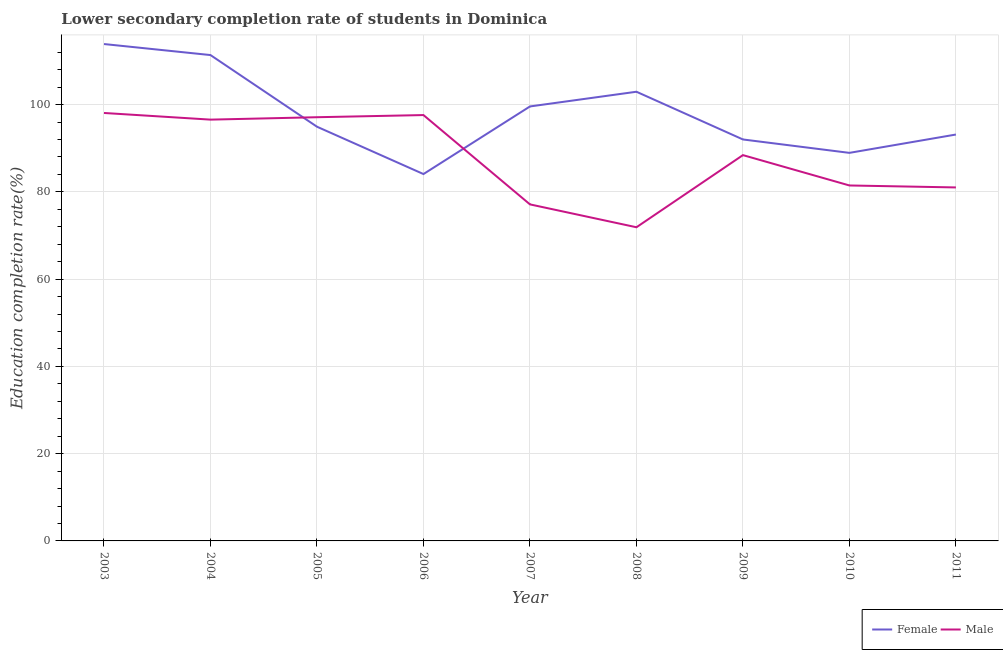Does the line corresponding to education completion rate of female students intersect with the line corresponding to education completion rate of male students?
Your answer should be very brief. Yes. What is the education completion rate of male students in 2005?
Your answer should be compact. 97.11. Across all years, what is the maximum education completion rate of male students?
Offer a terse response. 98.08. Across all years, what is the minimum education completion rate of male students?
Your answer should be compact. 71.89. In which year was the education completion rate of female students minimum?
Your answer should be very brief. 2006. What is the total education completion rate of female students in the graph?
Your response must be concise. 880.86. What is the difference between the education completion rate of male students in 2008 and that in 2011?
Provide a succinct answer. -9.13. What is the difference between the education completion rate of female students in 2005 and the education completion rate of male students in 2007?
Make the answer very short. 17.8. What is the average education completion rate of male students per year?
Provide a succinct answer. 87.7. In the year 2008, what is the difference between the education completion rate of female students and education completion rate of male students?
Make the answer very short. 31.06. In how many years, is the education completion rate of female students greater than 96 %?
Provide a succinct answer. 4. What is the ratio of the education completion rate of female students in 2007 to that in 2009?
Your answer should be very brief. 1.08. What is the difference between the highest and the second highest education completion rate of female students?
Your answer should be very brief. 2.53. What is the difference between the highest and the lowest education completion rate of female students?
Provide a short and direct response. 29.8. In how many years, is the education completion rate of female students greater than the average education completion rate of female students taken over all years?
Your answer should be compact. 4. Is the sum of the education completion rate of male students in 2006 and 2010 greater than the maximum education completion rate of female students across all years?
Provide a short and direct response. Yes. Is the education completion rate of female students strictly greater than the education completion rate of male students over the years?
Your answer should be compact. No. How many years are there in the graph?
Your answer should be very brief. 9. What is the difference between two consecutive major ticks on the Y-axis?
Your answer should be very brief. 20. Does the graph contain any zero values?
Your answer should be compact. No. How many legend labels are there?
Ensure brevity in your answer.  2. What is the title of the graph?
Your answer should be very brief. Lower secondary completion rate of students in Dominica. What is the label or title of the Y-axis?
Give a very brief answer. Education completion rate(%). What is the Education completion rate(%) of Female in 2003?
Offer a terse response. 113.88. What is the Education completion rate(%) in Male in 2003?
Ensure brevity in your answer.  98.08. What is the Education completion rate(%) of Female in 2004?
Your answer should be compact. 111.35. What is the Education completion rate(%) of Male in 2004?
Provide a short and direct response. 96.56. What is the Education completion rate(%) of Female in 2005?
Offer a very short reply. 94.93. What is the Education completion rate(%) of Male in 2005?
Keep it short and to the point. 97.11. What is the Education completion rate(%) in Female in 2006?
Your answer should be compact. 84.08. What is the Education completion rate(%) in Male in 2006?
Make the answer very short. 97.6. What is the Education completion rate(%) in Female in 2007?
Provide a succinct answer. 99.58. What is the Education completion rate(%) of Male in 2007?
Offer a very short reply. 77.13. What is the Education completion rate(%) in Female in 2008?
Offer a very short reply. 102.95. What is the Education completion rate(%) of Male in 2008?
Your response must be concise. 71.89. What is the Education completion rate(%) in Female in 2009?
Offer a very short reply. 92.01. What is the Education completion rate(%) in Male in 2009?
Ensure brevity in your answer.  88.42. What is the Education completion rate(%) in Female in 2010?
Offer a very short reply. 88.94. What is the Education completion rate(%) of Male in 2010?
Your response must be concise. 81.47. What is the Education completion rate(%) of Female in 2011?
Provide a short and direct response. 93.14. What is the Education completion rate(%) in Male in 2011?
Your response must be concise. 81.01. Across all years, what is the maximum Education completion rate(%) in Female?
Make the answer very short. 113.88. Across all years, what is the maximum Education completion rate(%) of Male?
Ensure brevity in your answer.  98.08. Across all years, what is the minimum Education completion rate(%) in Female?
Ensure brevity in your answer.  84.08. Across all years, what is the minimum Education completion rate(%) in Male?
Provide a succinct answer. 71.89. What is the total Education completion rate(%) in Female in the graph?
Your answer should be very brief. 880.86. What is the total Education completion rate(%) in Male in the graph?
Your response must be concise. 789.27. What is the difference between the Education completion rate(%) in Female in 2003 and that in 2004?
Keep it short and to the point. 2.53. What is the difference between the Education completion rate(%) in Male in 2003 and that in 2004?
Give a very brief answer. 1.53. What is the difference between the Education completion rate(%) in Female in 2003 and that in 2005?
Your answer should be compact. 18.95. What is the difference between the Education completion rate(%) in Male in 2003 and that in 2005?
Provide a succinct answer. 0.98. What is the difference between the Education completion rate(%) of Female in 2003 and that in 2006?
Provide a short and direct response. 29.8. What is the difference between the Education completion rate(%) in Male in 2003 and that in 2006?
Your response must be concise. 0.48. What is the difference between the Education completion rate(%) in Female in 2003 and that in 2007?
Ensure brevity in your answer.  14.3. What is the difference between the Education completion rate(%) of Male in 2003 and that in 2007?
Offer a terse response. 20.95. What is the difference between the Education completion rate(%) of Female in 2003 and that in 2008?
Offer a terse response. 10.93. What is the difference between the Education completion rate(%) of Male in 2003 and that in 2008?
Offer a terse response. 26.2. What is the difference between the Education completion rate(%) of Female in 2003 and that in 2009?
Ensure brevity in your answer.  21.87. What is the difference between the Education completion rate(%) of Male in 2003 and that in 2009?
Your answer should be compact. 9.66. What is the difference between the Education completion rate(%) of Female in 2003 and that in 2010?
Your answer should be very brief. 24.94. What is the difference between the Education completion rate(%) of Male in 2003 and that in 2010?
Your answer should be compact. 16.62. What is the difference between the Education completion rate(%) of Female in 2003 and that in 2011?
Make the answer very short. 20.74. What is the difference between the Education completion rate(%) in Male in 2003 and that in 2011?
Provide a succinct answer. 17.07. What is the difference between the Education completion rate(%) in Female in 2004 and that in 2005?
Offer a very short reply. 16.42. What is the difference between the Education completion rate(%) in Male in 2004 and that in 2005?
Your answer should be compact. -0.55. What is the difference between the Education completion rate(%) in Female in 2004 and that in 2006?
Your response must be concise. 27.27. What is the difference between the Education completion rate(%) of Male in 2004 and that in 2006?
Your answer should be compact. -1.05. What is the difference between the Education completion rate(%) in Female in 2004 and that in 2007?
Provide a succinct answer. 11.78. What is the difference between the Education completion rate(%) in Male in 2004 and that in 2007?
Your response must be concise. 19.42. What is the difference between the Education completion rate(%) in Female in 2004 and that in 2008?
Your answer should be very brief. 8.41. What is the difference between the Education completion rate(%) in Male in 2004 and that in 2008?
Your answer should be compact. 24.67. What is the difference between the Education completion rate(%) of Female in 2004 and that in 2009?
Your answer should be very brief. 19.34. What is the difference between the Education completion rate(%) of Male in 2004 and that in 2009?
Ensure brevity in your answer.  8.14. What is the difference between the Education completion rate(%) in Female in 2004 and that in 2010?
Provide a succinct answer. 22.41. What is the difference between the Education completion rate(%) in Male in 2004 and that in 2010?
Offer a very short reply. 15.09. What is the difference between the Education completion rate(%) in Female in 2004 and that in 2011?
Your answer should be very brief. 18.21. What is the difference between the Education completion rate(%) of Male in 2004 and that in 2011?
Ensure brevity in your answer.  15.54. What is the difference between the Education completion rate(%) in Female in 2005 and that in 2006?
Ensure brevity in your answer.  10.85. What is the difference between the Education completion rate(%) in Male in 2005 and that in 2006?
Provide a short and direct response. -0.5. What is the difference between the Education completion rate(%) in Female in 2005 and that in 2007?
Your answer should be very brief. -4.64. What is the difference between the Education completion rate(%) in Male in 2005 and that in 2007?
Your answer should be very brief. 19.98. What is the difference between the Education completion rate(%) of Female in 2005 and that in 2008?
Offer a terse response. -8.01. What is the difference between the Education completion rate(%) in Male in 2005 and that in 2008?
Your answer should be very brief. 25.22. What is the difference between the Education completion rate(%) of Female in 2005 and that in 2009?
Your answer should be very brief. 2.92. What is the difference between the Education completion rate(%) of Male in 2005 and that in 2009?
Your response must be concise. 8.69. What is the difference between the Education completion rate(%) of Female in 2005 and that in 2010?
Make the answer very short. 5.99. What is the difference between the Education completion rate(%) in Male in 2005 and that in 2010?
Offer a terse response. 15.64. What is the difference between the Education completion rate(%) of Female in 2005 and that in 2011?
Provide a short and direct response. 1.79. What is the difference between the Education completion rate(%) of Male in 2005 and that in 2011?
Ensure brevity in your answer.  16.09. What is the difference between the Education completion rate(%) in Female in 2006 and that in 2007?
Offer a terse response. -15.5. What is the difference between the Education completion rate(%) of Male in 2006 and that in 2007?
Your response must be concise. 20.47. What is the difference between the Education completion rate(%) in Female in 2006 and that in 2008?
Offer a terse response. -18.86. What is the difference between the Education completion rate(%) in Male in 2006 and that in 2008?
Provide a short and direct response. 25.72. What is the difference between the Education completion rate(%) in Female in 2006 and that in 2009?
Ensure brevity in your answer.  -7.93. What is the difference between the Education completion rate(%) in Male in 2006 and that in 2009?
Make the answer very short. 9.18. What is the difference between the Education completion rate(%) of Female in 2006 and that in 2010?
Provide a succinct answer. -4.86. What is the difference between the Education completion rate(%) in Male in 2006 and that in 2010?
Your response must be concise. 16.14. What is the difference between the Education completion rate(%) of Female in 2006 and that in 2011?
Ensure brevity in your answer.  -9.06. What is the difference between the Education completion rate(%) of Male in 2006 and that in 2011?
Give a very brief answer. 16.59. What is the difference between the Education completion rate(%) in Female in 2007 and that in 2008?
Provide a succinct answer. -3.37. What is the difference between the Education completion rate(%) in Male in 2007 and that in 2008?
Provide a succinct answer. 5.24. What is the difference between the Education completion rate(%) in Female in 2007 and that in 2009?
Give a very brief answer. 7.56. What is the difference between the Education completion rate(%) of Male in 2007 and that in 2009?
Provide a short and direct response. -11.29. What is the difference between the Education completion rate(%) of Female in 2007 and that in 2010?
Your answer should be compact. 10.64. What is the difference between the Education completion rate(%) in Male in 2007 and that in 2010?
Keep it short and to the point. -4.33. What is the difference between the Education completion rate(%) of Female in 2007 and that in 2011?
Provide a short and direct response. 6.44. What is the difference between the Education completion rate(%) of Male in 2007 and that in 2011?
Offer a terse response. -3.88. What is the difference between the Education completion rate(%) in Female in 2008 and that in 2009?
Keep it short and to the point. 10.93. What is the difference between the Education completion rate(%) in Male in 2008 and that in 2009?
Give a very brief answer. -16.53. What is the difference between the Education completion rate(%) of Female in 2008 and that in 2010?
Offer a very short reply. 14.01. What is the difference between the Education completion rate(%) of Male in 2008 and that in 2010?
Offer a very short reply. -9.58. What is the difference between the Education completion rate(%) of Female in 2008 and that in 2011?
Offer a very short reply. 9.81. What is the difference between the Education completion rate(%) of Male in 2008 and that in 2011?
Provide a succinct answer. -9.13. What is the difference between the Education completion rate(%) of Female in 2009 and that in 2010?
Offer a very short reply. 3.07. What is the difference between the Education completion rate(%) in Male in 2009 and that in 2010?
Your response must be concise. 6.95. What is the difference between the Education completion rate(%) in Female in 2009 and that in 2011?
Your response must be concise. -1.13. What is the difference between the Education completion rate(%) of Male in 2009 and that in 2011?
Make the answer very short. 7.41. What is the difference between the Education completion rate(%) in Female in 2010 and that in 2011?
Make the answer very short. -4.2. What is the difference between the Education completion rate(%) of Male in 2010 and that in 2011?
Ensure brevity in your answer.  0.45. What is the difference between the Education completion rate(%) of Female in 2003 and the Education completion rate(%) of Male in 2004?
Your answer should be compact. 17.32. What is the difference between the Education completion rate(%) in Female in 2003 and the Education completion rate(%) in Male in 2005?
Give a very brief answer. 16.77. What is the difference between the Education completion rate(%) of Female in 2003 and the Education completion rate(%) of Male in 2006?
Your answer should be very brief. 16.28. What is the difference between the Education completion rate(%) of Female in 2003 and the Education completion rate(%) of Male in 2007?
Your response must be concise. 36.75. What is the difference between the Education completion rate(%) in Female in 2003 and the Education completion rate(%) in Male in 2008?
Ensure brevity in your answer.  41.99. What is the difference between the Education completion rate(%) of Female in 2003 and the Education completion rate(%) of Male in 2009?
Give a very brief answer. 25.46. What is the difference between the Education completion rate(%) in Female in 2003 and the Education completion rate(%) in Male in 2010?
Provide a succinct answer. 32.41. What is the difference between the Education completion rate(%) of Female in 2003 and the Education completion rate(%) of Male in 2011?
Provide a short and direct response. 32.87. What is the difference between the Education completion rate(%) in Female in 2004 and the Education completion rate(%) in Male in 2005?
Offer a very short reply. 14.25. What is the difference between the Education completion rate(%) of Female in 2004 and the Education completion rate(%) of Male in 2006?
Make the answer very short. 13.75. What is the difference between the Education completion rate(%) of Female in 2004 and the Education completion rate(%) of Male in 2007?
Your answer should be very brief. 34.22. What is the difference between the Education completion rate(%) in Female in 2004 and the Education completion rate(%) in Male in 2008?
Keep it short and to the point. 39.47. What is the difference between the Education completion rate(%) in Female in 2004 and the Education completion rate(%) in Male in 2009?
Provide a short and direct response. 22.93. What is the difference between the Education completion rate(%) of Female in 2004 and the Education completion rate(%) of Male in 2010?
Give a very brief answer. 29.89. What is the difference between the Education completion rate(%) of Female in 2004 and the Education completion rate(%) of Male in 2011?
Keep it short and to the point. 30.34. What is the difference between the Education completion rate(%) in Female in 2005 and the Education completion rate(%) in Male in 2006?
Make the answer very short. -2.67. What is the difference between the Education completion rate(%) of Female in 2005 and the Education completion rate(%) of Male in 2007?
Your response must be concise. 17.8. What is the difference between the Education completion rate(%) of Female in 2005 and the Education completion rate(%) of Male in 2008?
Your answer should be compact. 23.05. What is the difference between the Education completion rate(%) in Female in 2005 and the Education completion rate(%) in Male in 2009?
Provide a short and direct response. 6.51. What is the difference between the Education completion rate(%) of Female in 2005 and the Education completion rate(%) of Male in 2010?
Provide a short and direct response. 13.47. What is the difference between the Education completion rate(%) of Female in 2005 and the Education completion rate(%) of Male in 2011?
Your answer should be very brief. 13.92. What is the difference between the Education completion rate(%) of Female in 2006 and the Education completion rate(%) of Male in 2007?
Your answer should be compact. 6.95. What is the difference between the Education completion rate(%) in Female in 2006 and the Education completion rate(%) in Male in 2008?
Give a very brief answer. 12.19. What is the difference between the Education completion rate(%) of Female in 2006 and the Education completion rate(%) of Male in 2009?
Your answer should be compact. -4.34. What is the difference between the Education completion rate(%) in Female in 2006 and the Education completion rate(%) in Male in 2010?
Offer a terse response. 2.61. What is the difference between the Education completion rate(%) in Female in 2006 and the Education completion rate(%) in Male in 2011?
Your answer should be compact. 3.07. What is the difference between the Education completion rate(%) of Female in 2007 and the Education completion rate(%) of Male in 2008?
Your response must be concise. 27.69. What is the difference between the Education completion rate(%) in Female in 2007 and the Education completion rate(%) in Male in 2009?
Give a very brief answer. 11.16. What is the difference between the Education completion rate(%) of Female in 2007 and the Education completion rate(%) of Male in 2010?
Ensure brevity in your answer.  18.11. What is the difference between the Education completion rate(%) of Female in 2007 and the Education completion rate(%) of Male in 2011?
Keep it short and to the point. 18.56. What is the difference between the Education completion rate(%) in Female in 2008 and the Education completion rate(%) in Male in 2009?
Ensure brevity in your answer.  14.52. What is the difference between the Education completion rate(%) in Female in 2008 and the Education completion rate(%) in Male in 2010?
Your answer should be compact. 21.48. What is the difference between the Education completion rate(%) of Female in 2008 and the Education completion rate(%) of Male in 2011?
Provide a short and direct response. 21.93. What is the difference between the Education completion rate(%) in Female in 2009 and the Education completion rate(%) in Male in 2010?
Keep it short and to the point. 10.55. What is the difference between the Education completion rate(%) in Female in 2009 and the Education completion rate(%) in Male in 2011?
Keep it short and to the point. 11. What is the difference between the Education completion rate(%) in Female in 2010 and the Education completion rate(%) in Male in 2011?
Offer a terse response. 7.92. What is the average Education completion rate(%) in Female per year?
Offer a very short reply. 97.87. What is the average Education completion rate(%) of Male per year?
Your answer should be very brief. 87.7. In the year 2003, what is the difference between the Education completion rate(%) of Female and Education completion rate(%) of Male?
Offer a terse response. 15.8. In the year 2004, what is the difference between the Education completion rate(%) of Female and Education completion rate(%) of Male?
Keep it short and to the point. 14.8. In the year 2005, what is the difference between the Education completion rate(%) of Female and Education completion rate(%) of Male?
Keep it short and to the point. -2.17. In the year 2006, what is the difference between the Education completion rate(%) of Female and Education completion rate(%) of Male?
Offer a terse response. -13.52. In the year 2007, what is the difference between the Education completion rate(%) in Female and Education completion rate(%) in Male?
Ensure brevity in your answer.  22.44. In the year 2008, what is the difference between the Education completion rate(%) of Female and Education completion rate(%) of Male?
Your answer should be compact. 31.06. In the year 2009, what is the difference between the Education completion rate(%) of Female and Education completion rate(%) of Male?
Provide a succinct answer. 3.59. In the year 2010, what is the difference between the Education completion rate(%) in Female and Education completion rate(%) in Male?
Provide a succinct answer. 7.47. In the year 2011, what is the difference between the Education completion rate(%) in Female and Education completion rate(%) in Male?
Your answer should be very brief. 12.13. What is the ratio of the Education completion rate(%) in Female in 2003 to that in 2004?
Your answer should be very brief. 1.02. What is the ratio of the Education completion rate(%) of Male in 2003 to that in 2004?
Keep it short and to the point. 1.02. What is the ratio of the Education completion rate(%) in Female in 2003 to that in 2005?
Your answer should be very brief. 1.2. What is the ratio of the Education completion rate(%) of Female in 2003 to that in 2006?
Give a very brief answer. 1.35. What is the ratio of the Education completion rate(%) in Female in 2003 to that in 2007?
Your answer should be compact. 1.14. What is the ratio of the Education completion rate(%) of Male in 2003 to that in 2007?
Keep it short and to the point. 1.27. What is the ratio of the Education completion rate(%) of Female in 2003 to that in 2008?
Your answer should be compact. 1.11. What is the ratio of the Education completion rate(%) of Male in 2003 to that in 2008?
Your answer should be compact. 1.36. What is the ratio of the Education completion rate(%) of Female in 2003 to that in 2009?
Ensure brevity in your answer.  1.24. What is the ratio of the Education completion rate(%) of Male in 2003 to that in 2009?
Your response must be concise. 1.11. What is the ratio of the Education completion rate(%) in Female in 2003 to that in 2010?
Offer a very short reply. 1.28. What is the ratio of the Education completion rate(%) of Male in 2003 to that in 2010?
Offer a very short reply. 1.2. What is the ratio of the Education completion rate(%) in Female in 2003 to that in 2011?
Offer a terse response. 1.22. What is the ratio of the Education completion rate(%) in Male in 2003 to that in 2011?
Offer a very short reply. 1.21. What is the ratio of the Education completion rate(%) of Female in 2004 to that in 2005?
Give a very brief answer. 1.17. What is the ratio of the Education completion rate(%) in Male in 2004 to that in 2005?
Make the answer very short. 0.99. What is the ratio of the Education completion rate(%) of Female in 2004 to that in 2006?
Offer a very short reply. 1.32. What is the ratio of the Education completion rate(%) of Male in 2004 to that in 2006?
Offer a very short reply. 0.99. What is the ratio of the Education completion rate(%) of Female in 2004 to that in 2007?
Your answer should be compact. 1.12. What is the ratio of the Education completion rate(%) in Male in 2004 to that in 2007?
Offer a terse response. 1.25. What is the ratio of the Education completion rate(%) of Female in 2004 to that in 2008?
Your answer should be compact. 1.08. What is the ratio of the Education completion rate(%) in Male in 2004 to that in 2008?
Offer a very short reply. 1.34. What is the ratio of the Education completion rate(%) in Female in 2004 to that in 2009?
Give a very brief answer. 1.21. What is the ratio of the Education completion rate(%) of Male in 2004 to that in 2009?
Make the answer very short. 1.09. What is the ratio of the Education completion rate(%) of Female in 2004 to that in 2010?
Your answer should be compact. 1.25. What is the ratio of the Education completion rate(%) of Male in 2004 to that in 2010?
Provide a succinct answer. 1.19. What is the ratio of the Education completion rate(%) of Female in 2004 to that in 2011?
Provide a succinct answer. 1.2. What is the ratio of the Education completion rate(%) of Male in 2004 to that in 2011?
Make the answer very short. 1.19. What is the ratio of the Education completion rate(%) in Female in 2005 to that in 2006?
Your answer should be compact. 1.13. What is the ratio of the Education completion rate(%) of Male in 2005 to that in 2006?
Give a very brief answer. 0.99. What is the ratio of the Education completion rate(%) in Female in 2005 to that in 2007?
Your response must be concise. 0.95. What is the ratio of the Education completion rate(%) of Male in 2005 to that in 2007?
Provide a succinct answer. 1.26. What is the ratio of the Education completion rate(%) in Female in 2005 to that in 2008?
Provide a succinct answer. 0.92. What is the ratio of the Education completion rate(%) of Male in 2005 to that in 2008?
Ensure brevity in your answer.  1.35. What is the ratio of the Education completion rate(%) in Female in 2005 to that in 2009?
Provide a short and direct response. 1.03. What is the ratio of the Education completion rate(%) in Male in 2005 to that in 2009?
Your answer should be very brief. 1.1. What is the ratio of the Education completion rate(%) of Female in 2005 to that in 2010?
Offer a very short reply. 1.07. What is the ratio of the Education completion rate(%) of Male in 2005 to that in 2010?
Your answer should be very brief. 1.19. What is the ratio of the Education completion rate(%) in Female in 2005 to that in 2011?
Give a very brief answer. 1.02. What is the ratio of the Education completion rate(%) in Male in 2005 to that in 2011?
Offer a very short reply. 1.2. What is the ratio of the Education completion rate(%) of Female in 2006 to that in 2007?
Ensure brevity in your answer.  0.84. What is the ratio of the Education completion rate(%) in Male in 2006 to that in 2007?
Offer a very short reply. 1.27. What is the ratio of the Education completion rate(%) of Female in 2006 to that in 2008?
Give a very brief answer. 0.82. What is the ratio of the Education completion rate(%) of Male in 2006 to that in 2008?
Make the answer very short. 1.36. What is the ratio of the Education completion rate(%) in Female in 2006 to that in 2009?
Offer a very short reply. 0.91. What is the ratio of the Education completion rate(%) in Male in 2006 to that in 2009?
Keep it short and to the point. 1.1. What is the ratio of the Education completion rate(%) of Female in 2006 to that in 2010?
Keep it short and to the point. 0.95. What is the ratio of the Education completion rate(%) of Male in 2006 to that in 2010?
Your response must be concise. 1.2. What is the ratio of the Education completion rate(%) of Female in 2006 to that in 2011?
Your answer should be compact. 0.9. What is the ratio of the Education completion rate(%) of Male in 2006 to that in 2011?
Make the answer very short. 1.2. What is the ratio of the Education completion rate(%) of Female in 2007 to that in 2008?
Offer a terse response. 0.97. What is the ratio of the Education completion rate(%) of Male in 2007 to that in 2008?
Offer a terse response. 1.07. What is the ratio of the Education completion rate(%) of Female in 2007 to that in 2009?
Offer a terse response. 1.08. What is the ratio of the Education completion rate(%) of Male in 2007 to that in 2009?
Offer a very short reply. 0.87. What is the ratio of the Education completion rate(%) of Female in 2007 to that in 2010?
Offer a very short reply. 1.12. What is the ratio of the Education completion rate(%) in Male in 2007 to that in 2010?
Your response must be concise. 0.95. What is the ratio of the Education completion rate(%) in Female in 2007 to that in 2011?
Your answer should be very brief. 1.07. What is the ratio of the Education completion rate(%) of Male in 2007 to that in 2011?
Provide a short and direct response. 0.95. What is the ratio of the Education completion rate(%) of Female in 2008 to that in 2009?
Your answer should be compact. 1.12. What is the ratio of the Education completion rate(%) of Male in 2008 to that in 2009?
Your response must be concise. 0.81. What is the ratio of the Education completion rate(%) in Female in 2008 to that in 2010?
Offer a very short reply. 1.16. What is the ratio of the Education completion rate(%) in Male in 2008 to that in 2010?
Offer a terse response. 0.88. What is the ratio of the Education completion rate(%) of Female in 2008 to that in 2011?
Your answer should be very brief. 1.11. What is the ratio of the Education completion rate(%) of Male in 2008 to that in 2011?
Provide a short and direct response. 0.89. What is the ratio of the Education completion rate(%) in Female in 2009 to that in 2010?
Keep it short and to the point. 1.03. What is the ratio of the Education completion rate(%) in Male in 2009 to that in 2010?
Provide a succinct answer. 1.09. What is the ratio of the Education completion rate(%) in Female in 2009 to that in 2011?
Offer a terse response. 0.99. What is the ratio of the Education completion rate(%) in Male in 2009 to that in 2011?
Give a very brief answer. 1.09. What is the ratio of the Education completion rate(%) in Female in 2010 to that in 2011?
Make the answer very short. 0.95. What is the ratio of the Education completion rate(%) of Male in 2010 to that in 2011?
Offer a very short reply. 1.01. What is the difference between the highest and the second highest Education completion rate(%) of Female?
Ensure brevity in your answer.  2.53. What is the difference between the highest and the second highest Education completion rate(%) in Male?
Offer a terse response. 0.48. What is the difference between the highest and the lowest Education completion rate(%) in Female?
Provide a short and direct response. 29.8. What is the difference between the highest and the lowest Education completion rate(%) of Male?
Your response must be concise. 26.2. 